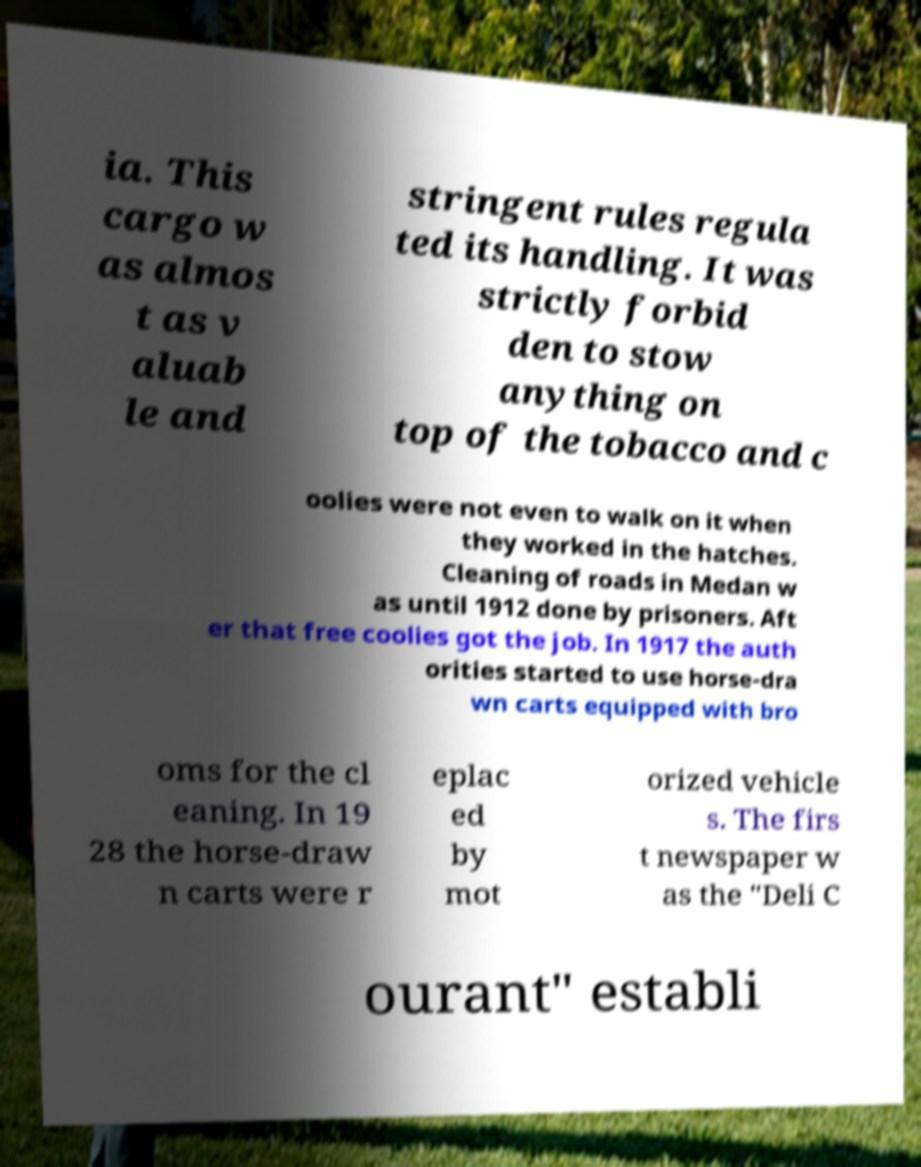What messages or text are displayed in this image? I need them in a readable, typed format. ia. This cargo w as almos t as v aluab le and stringent rules regula ted its handling. It was strictly forbid den to stow anything on top of the tobacco and c oolies were not even to walk on it when they worked in the hatches. Cleaning of roads in Medan w as until 1912 done by prisoners. Aft er that free coolies got the job. In 1917 the auth orities started to use horse-dra wn carts equipped with bro oms for the cl eaning. In 19 28 the horse-draw n carts were r eplac ed by mot orized vehicle s. The firs t newspaper w as the "Deli C ourant" establi 